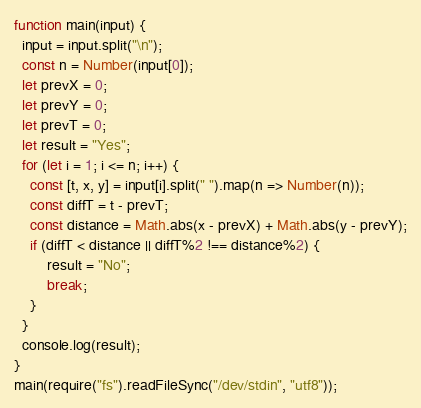<code> <loc_0><loc_0><loc_500><loc_500><_TypeScript_>function main(input) {
  input = input.split("\n");
  const n = Number(input[0]);
  let prevX = 0;
  let prevY = 0;
  let prevT = 0;
  let result = "Yes";
  for (let i = 1; i <= n; i++) {
    const [t, x, y] = input[i].split(" ").map(n => Number(n));
    const diffT = t - prevT;
    const distance = Math.abs(x - prevX) + Math.abs(y - prevY);
    if (diffT < distance || diffT%2 !== distance%2) {
      	result = "No";
        break;
    }
  }
  console.log(result);
}
main(require("fs").readFileSync("/dev/stdin", "utf8"));
</code> 